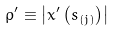Convert formula to latex. <formula><loc_0><loc_0><loc_500><loc_500>\rho ^ { \prime } \equiv \left | x ^ { \prime } \left ( s _ { \left ( j \right ) } \right ) \right |</formula> 